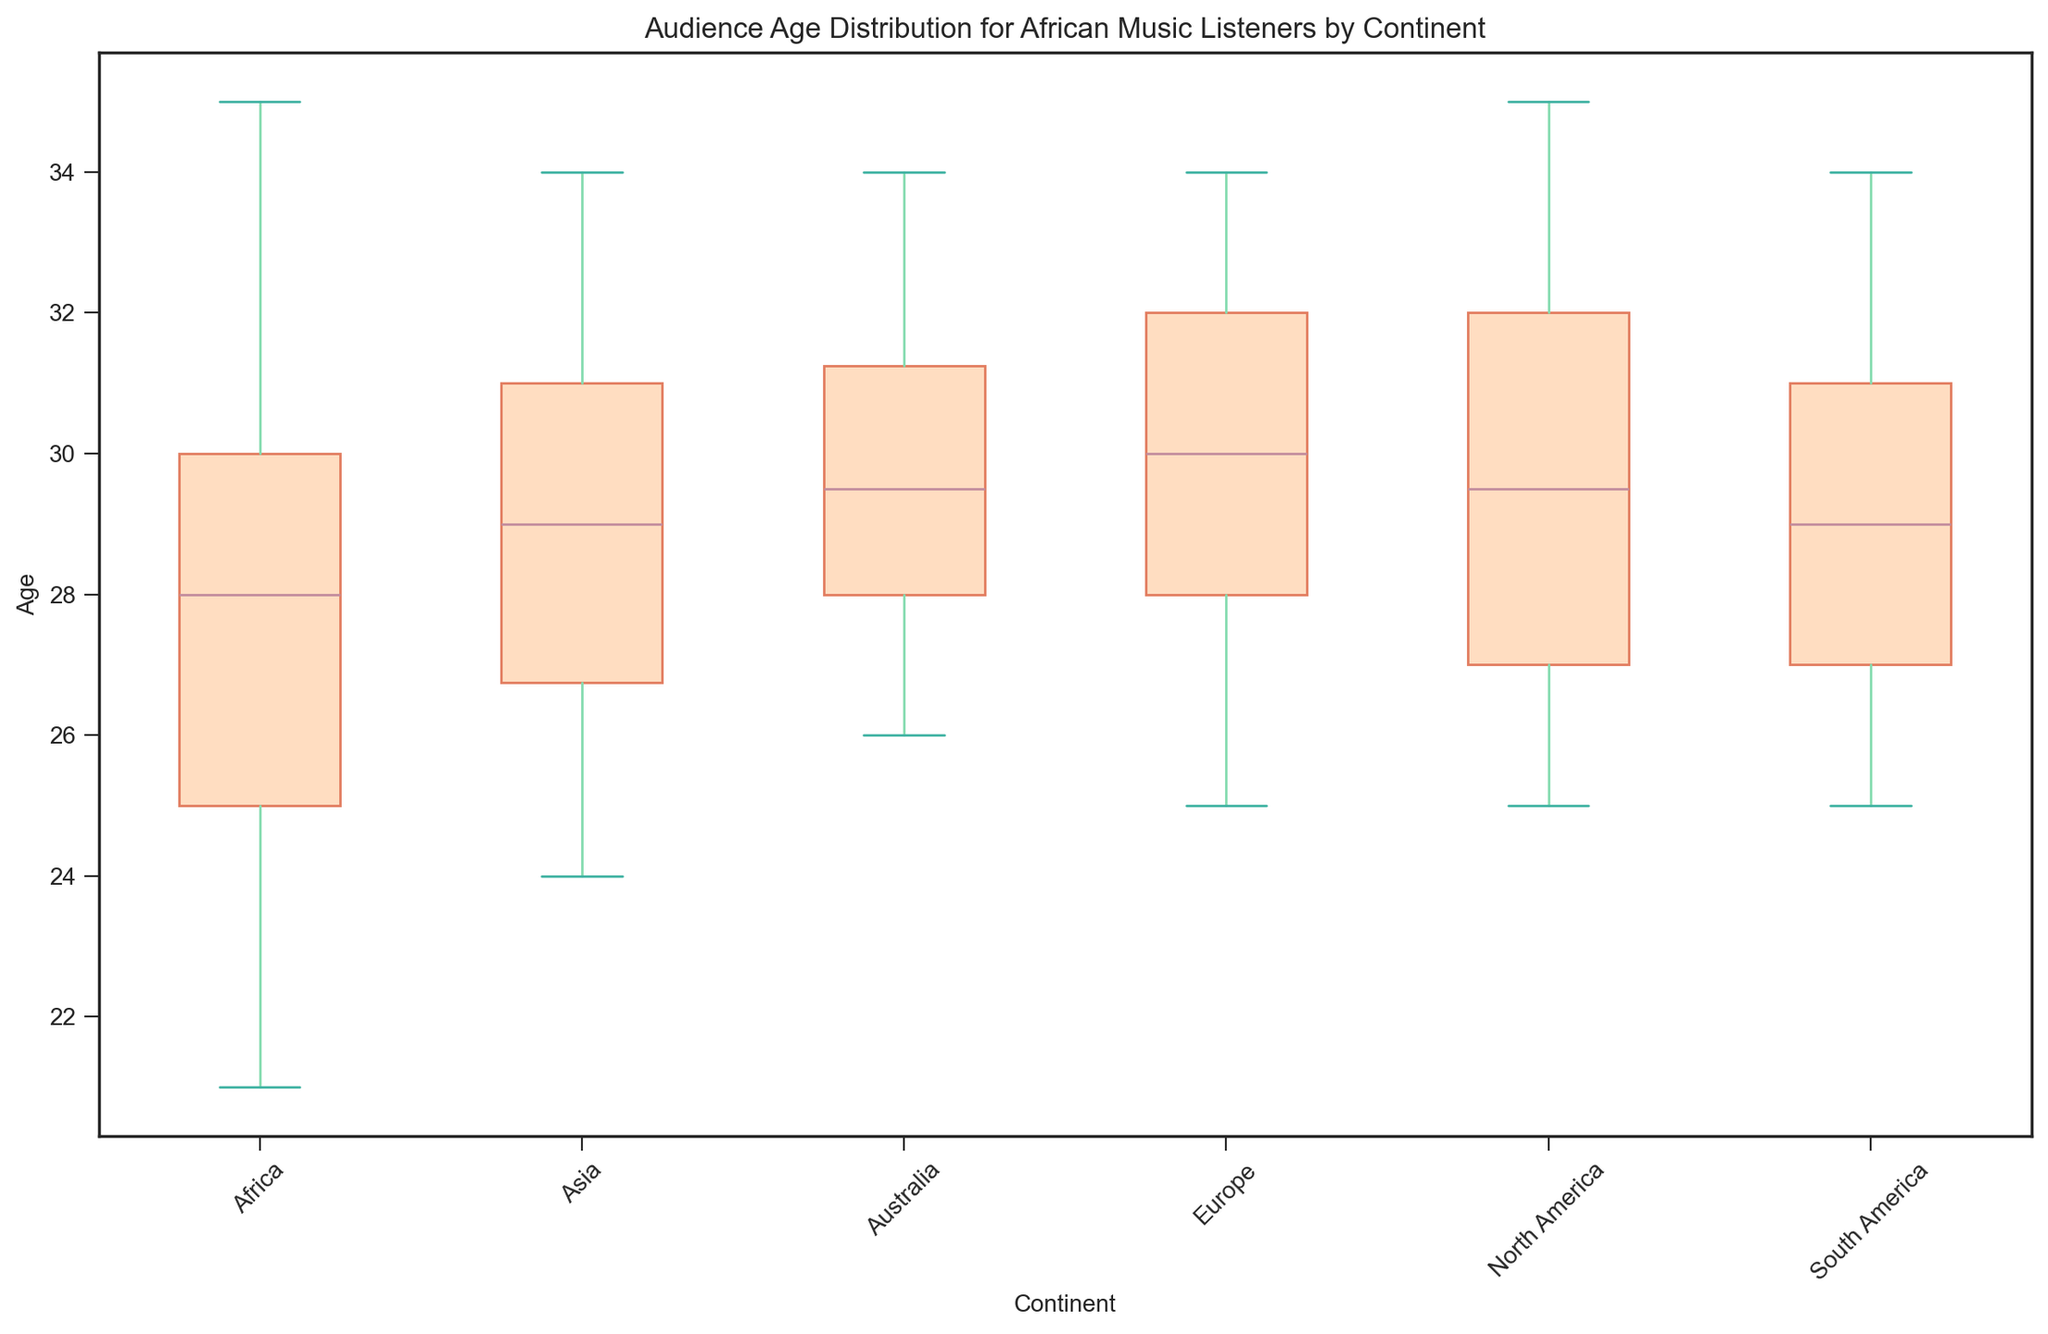Which continent has the highest median age for African music listeners? By comparing the medians on the box plot, we can see that North America has the highest median age.
Answer: North America Which continent has the smallest interquartile range (IQR) for the age of African music listeners? Compare the height of the boxes (which represent the IQR) for each continent. Europe has the smallest interquartile range.
Answer: Europe How does the median age of African music listeners in Asia compare to that in Europe? By comparing the medians in the box plot, we see that the median age in Asia is slightly lower than that in Europe.
Answer: Slightly lower What is the range of ages for African music listeners in South America? The range is identified by the difference between the maximum and minimum points in the whiskers for South America. The range is from 25 to 34.
Answer: 25 to 34 How does the overall age variation (range from min to max) in Africa compare to that in North America? Compare the whiskers' lengths for Africa and North America. Africa's range is smaller, going from 21 to 35, while North America's range also goes from 25 to 35.
Answer: Smaller in Africa Which continent shows the most outliers in the age distribution of African music listeners? Observe the outliers marked as individual points beyond the whiskers. North America and Australia show the most outliers.
Answer: North America and Australia Is the median age of African music listeners in Australia higher or lower than the median age in Asia? By comparing the median lines in the box plot for Australia and Asia, we see that Australia's median age is higher.
Answer: Higher Which continent has the widest spread of age data? The widest spread is determined by the length of the whiskers. Both North America and South America have whiskers from 25 to 34, showing the widest spread.
Answer: North America and South America What is the average age of the upper quartile (75th percentile) for African music listeners in Europe? The upper quartile (75th percentile) is found at the top edge of the box. In Europe, it is about 32.
Answer: 32 How does the median age in Africa compare to the entire dataset's median age? Compute the median for Africa and compare it to the global median (from all continents combined, approximately 29). The median age in Africa is roughly the same as the overall median.
Answer: Roughly the same 